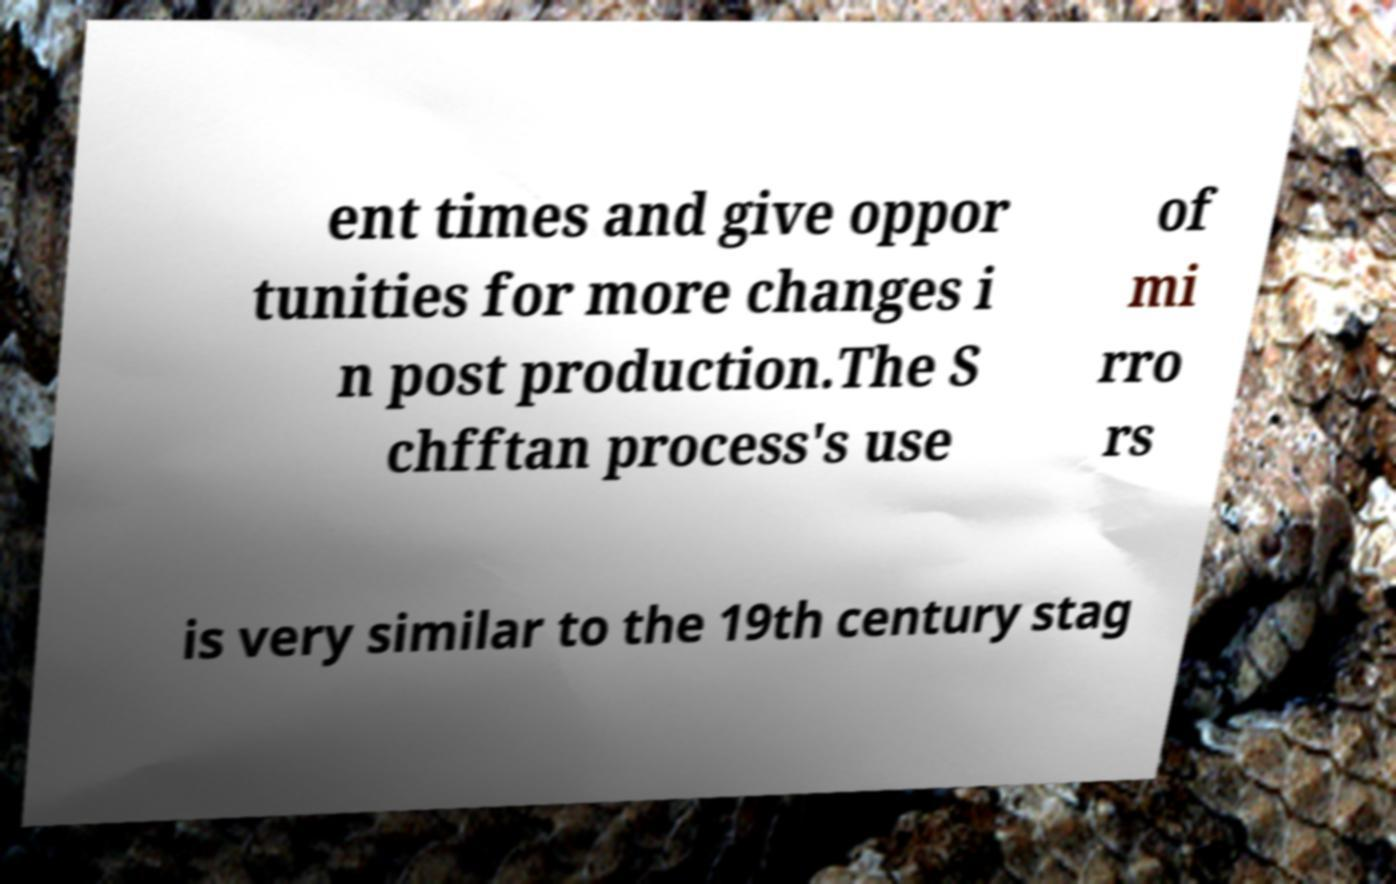What messages or text are displayed in this image? I need them in a readable, typed format. ent times and give oppor tunities for more changes i n post production.The S chfftan process's use of mi rro rs is very similar to the 19th century stag 